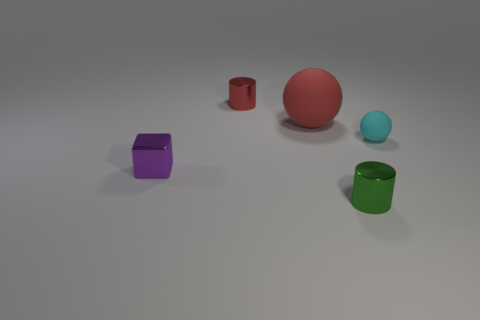Are there any yellow cubes made of the same material as the purple thing? no 